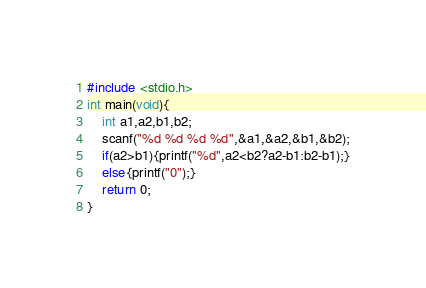Convert code to text. <code><loc_0><loc_0><loc_500><loc_500><_C_>#include <stdio.h>
int main(void){
	int a1,a2,b1,b2;
	scanf("%d %d %d %d",&a1,&a2,&b1,&b2);
	if(a2>b1){printf("%d",a2<b2?a2-b1:b2-b1);}
	else{printf("0");}
	return 0;
}</code> 